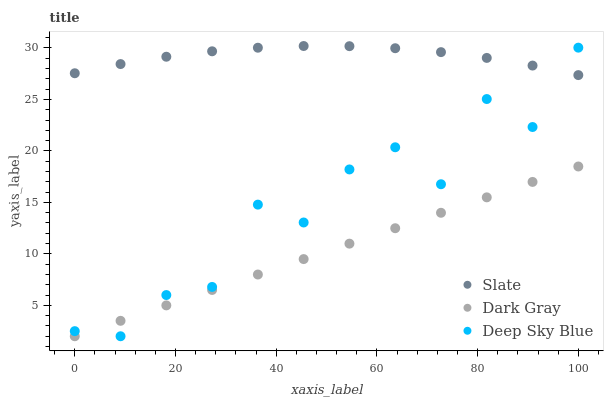Does Dark Gray have the minimum area under the curve?
Answer yes or no. Yes. Does Slate have the maximum area under the curve?
Answer yes or no. Yes. Does Deep Sky Blue have the minimum area under the curve?
Answer yes or no. No. Does Deep Sky Blue have the maximum area under the curve?
Answer yes or no. No. Is Dark Gray the smoothest?
Answer yes or no. Yes. Is Deep Sky Blue the roughest?
Answer yes or no. Yes. Is Slate the smoothest?
Answer yes or no. No. Is Slate the roughest?
Answer yes or no. No. Does Dark Gray have the lowest value?
Answer yes or no. Yes. Does Slate have the lowest value?
Answer yes or no. No. Does Slate have the highest value?
Answer yes or no. Yes. Does Deep Sky Blue have the highest value?
Answer yes or no. No. Is Dark Gray less than Slate?
Answer yes or no. Yes. Is Slate greater than Dark Gray?
Answer yes or no. Yes. Does Slate intersect Deep Sky Blue?
Answer yes or no. Yes. Is Slate less than Deep Sky Blue?
Answer yes or no. No. Is Slate greater than Deep Sky Blue?
Answer yes or no. No. Does Dark Gray intersect Slate?
Answer yes or no. No. 